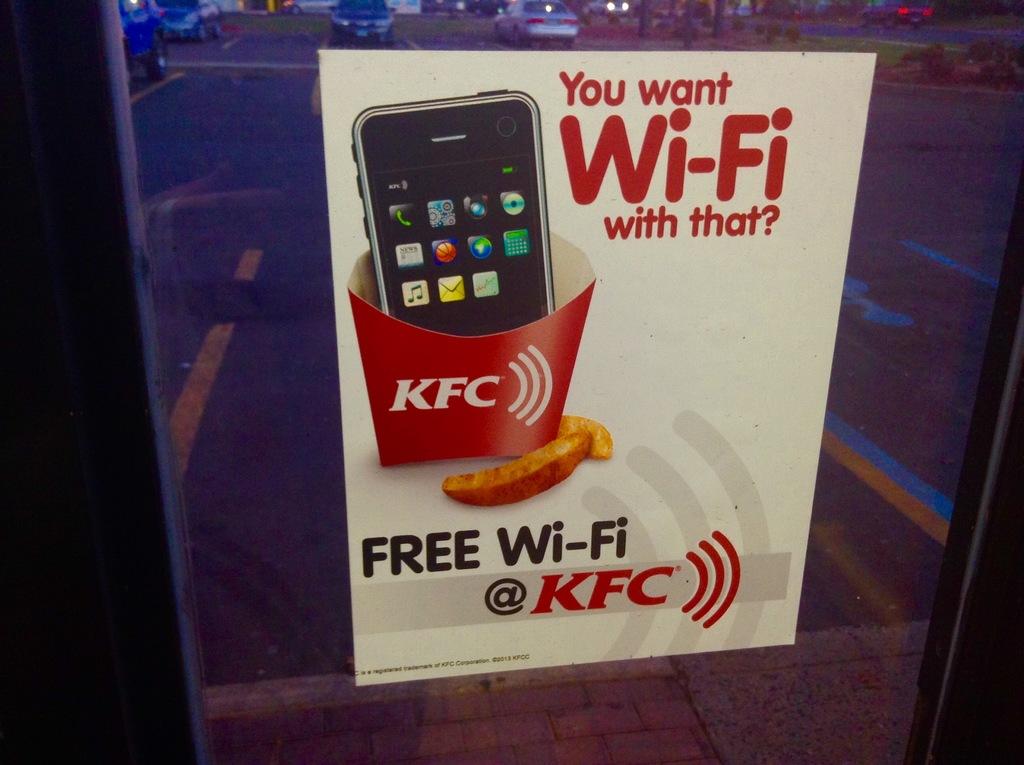What company is offering wi-fi?
Ensure brevity in your answer.  Kfc. What is the first word written in black?
Your answer should be compact. Free. 